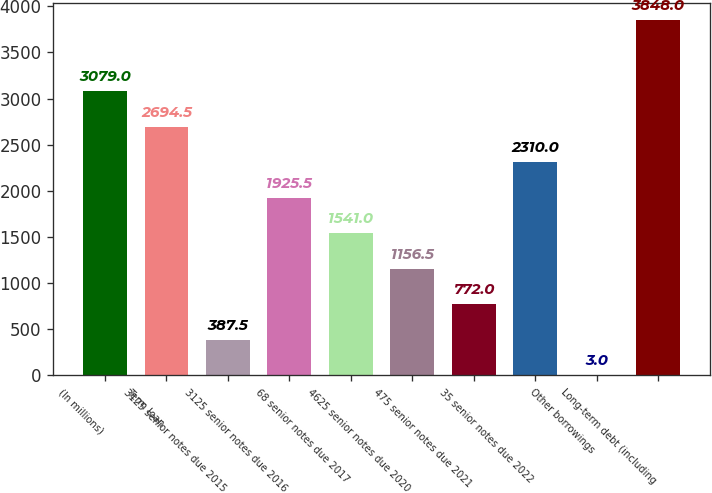<chart> <loc_0><loc_0><loc_500><loc_500><bar_chart><fcel>(In millions)<fcel>Term loan<fcel>3125 senior notes due 2015<fcel>3125 senior notes due 2016<fcel>68 senior notes due 2017<fcel>4625 senior notes due 2020<fcel>475 senior notes due 2021<fcel>35 senior notes due 2022<fcel>Other borrowings<fcel>Long-term debt (including<nl><fcel>3079<fcel>2694.5<fcel>387.5<fcel>1925.5<fcel>1541<fcel>1156.5<fcel>772<fcel>2310<fcel>3<fcel>3848<nl></chart> 